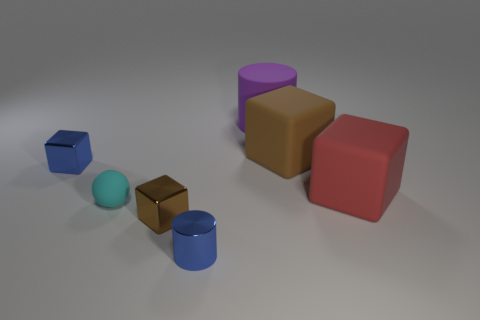The large block in front of the tiny metal cube that is to the left of the brown thing that is left of the large brown block is made of what material? The large block in question appears to have a rubber-like texture, consistent with the model's previous answer. However, considering its visual similarity to the other objects in the scene - mainly in terms of lighting and shadows which imply they're all rendered - it's also possible that it's made from a digital material mimicking rubber within a 3D modeling program. 